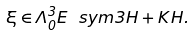Convert formula to latex. <formula><loc_0><loc_0><loc_500><loc_500>\xi \in \Lambda ^ { 3 } _ { 0 } E \ s y m 3 H + K H .</formula> 